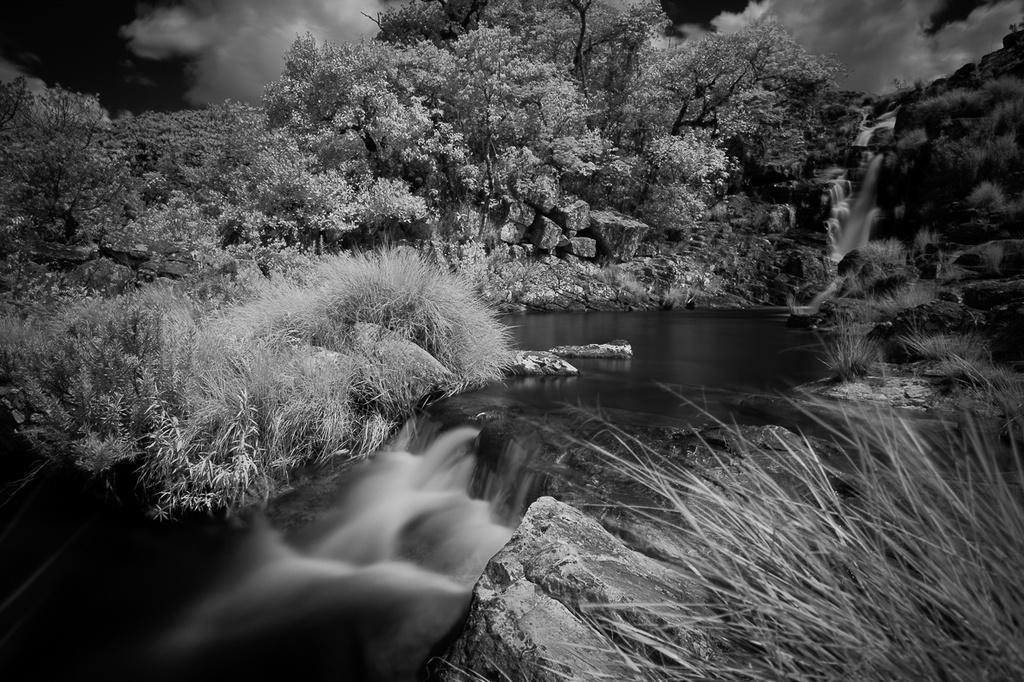Describe this image in one or two sentences. In this picture we can observe trees and rocks. In the right side there is some grass. We can observe a waterfall. In the background there is a sky with clouds. 